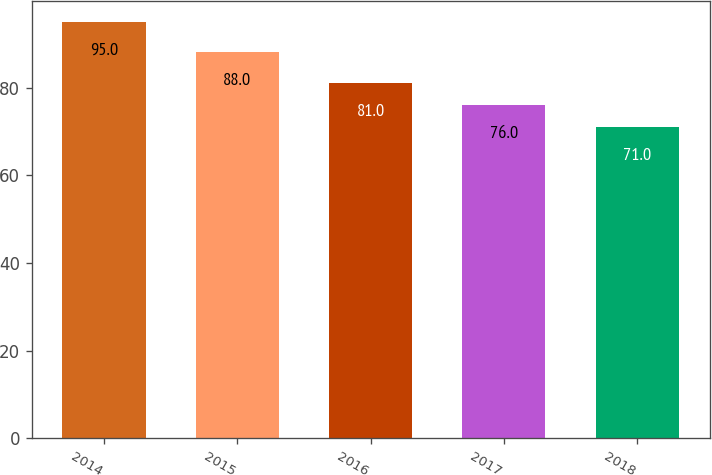Convert chart. <chart><loc_0><loc_0><loc_500><loc_500><bar_chart><fcel>2014<fcel>2015<fcel>2016<fcel>2017<fcel>2018<nl><fcel>95<fcel>88<fcel>81<fcel>76<fcel>71<nl></chart> 